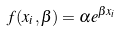<formula> <loc_0><loc_0><loc_500><loc_500>f ( x _ { i } , \beta ) = \alpha e ^ { \beta x _ { i } }</formula> 